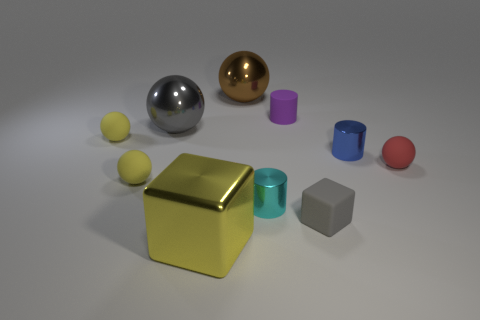What textures are visible on the objects? The objects exhibit a range of textures. The three spheres have a smooth, matte finish, while the metallic cubes have a glossy, reflective surface. The cylinders have a somewhat satin finish that strikes a balance between matte and shiny. How do these textures affect the overall visual quality of the image? The varied textures contribute to the visual interest of the scene by creating contrast. The matte objects absorb light and shift our focus to the reflective cubes that stand out with their sharp highlights and clear reflections. This diversifies the visual stimuli and adds depth to the composition. 